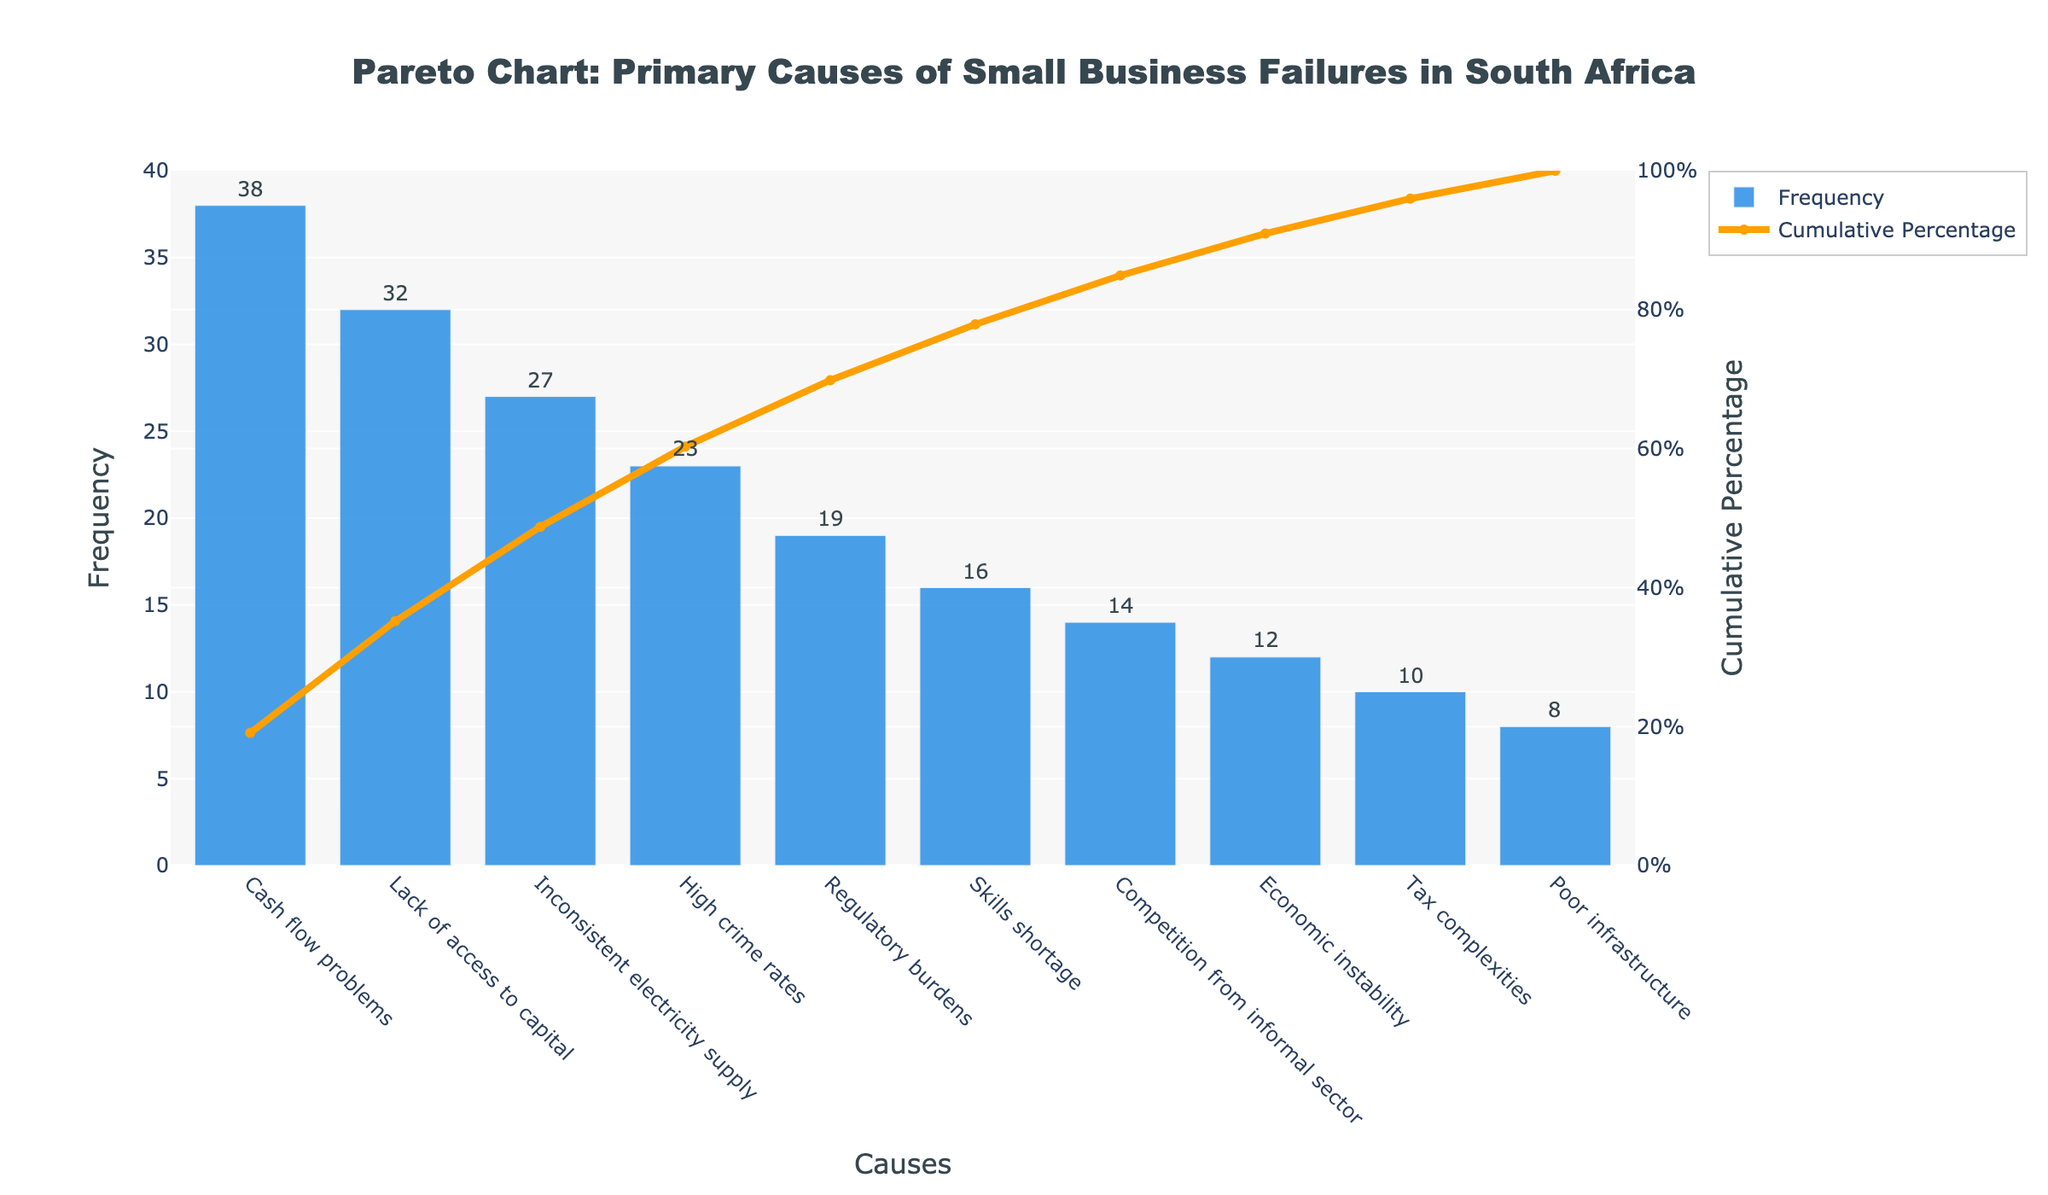What's the title of the figure? The title is located at the top of the figure and is meant to give an overview of the information presented in the chart.
Answer: Pareto Chart: Primary Causes of Small Business Failures in South Africa What's the cause with the highest frequency? By examining the height of the bars, the tallest bar represents the cause with the highest frequency.
Answer: Cash flow problems Which cause has a frequency of 19? The bars are labeled with their respective causes and frequencies. The bar with a frequency of 19 corresponds to a specific cause.
Answer: Regulatory burdens What is the cumulative percentage for 'High crime rates'? The scatter line representing the cumulative percentage intersects each cause. Locate 'High crime rates' and its corresponding value on the y-axis2.
Answer: 73.4% What is the combined frequency of 'Lack of access to capital' and 'Inconsistent electricity supply'? Add the frequencies of 'Lack of access to capital' and 'Inconsistent electricity supply'. 32 + 27 = 59.
Answer: 59 Which has a higher frequency: 'Skills shortage' or 'Economic instability'? Compare the bar heights or frequency values for 'Skills shortage' and 'Economic instability'. 'Skills shortage' has a frequency of 16 and 'Economic instability' has a frequency of 12.
Answer: Skills shortage How many causes have a frequency higher than 20? Identify and count the bars with frequencies greater than 20. These are 'Cash flow problems', 'Lack of access to capital', 'Inconsistent electricity supply', and 'High crime rates'.
Answer: 4 What's the cumulative percentage threshold where 'Regulatory burdens' lie? The cumulative percentage line intersects 'Regulatory burdens'. Refer to the y-axis on the right.
Answer: 91.3% Which cause is contributing the least to business failures? The shortest bar represents the cause with the lowest frequency.
Answer: Poor infrastructure What is the significance of the orange line in the chart? The orange line shows the cumulative percentage of the frequencies, highlighting how each cause cumulatively contributes to overall business failures.
Answer: Cumulative percentage 